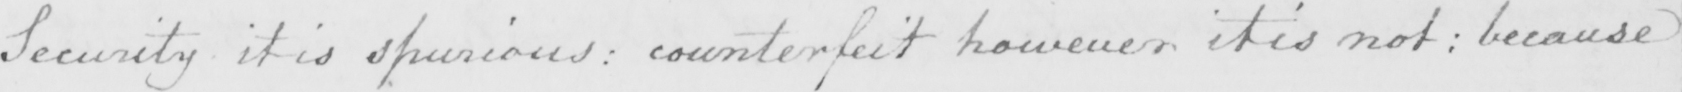Please transcribe the handwritten text in this image. Secuirty it is spurious :  counterfeit however it is not :  because 